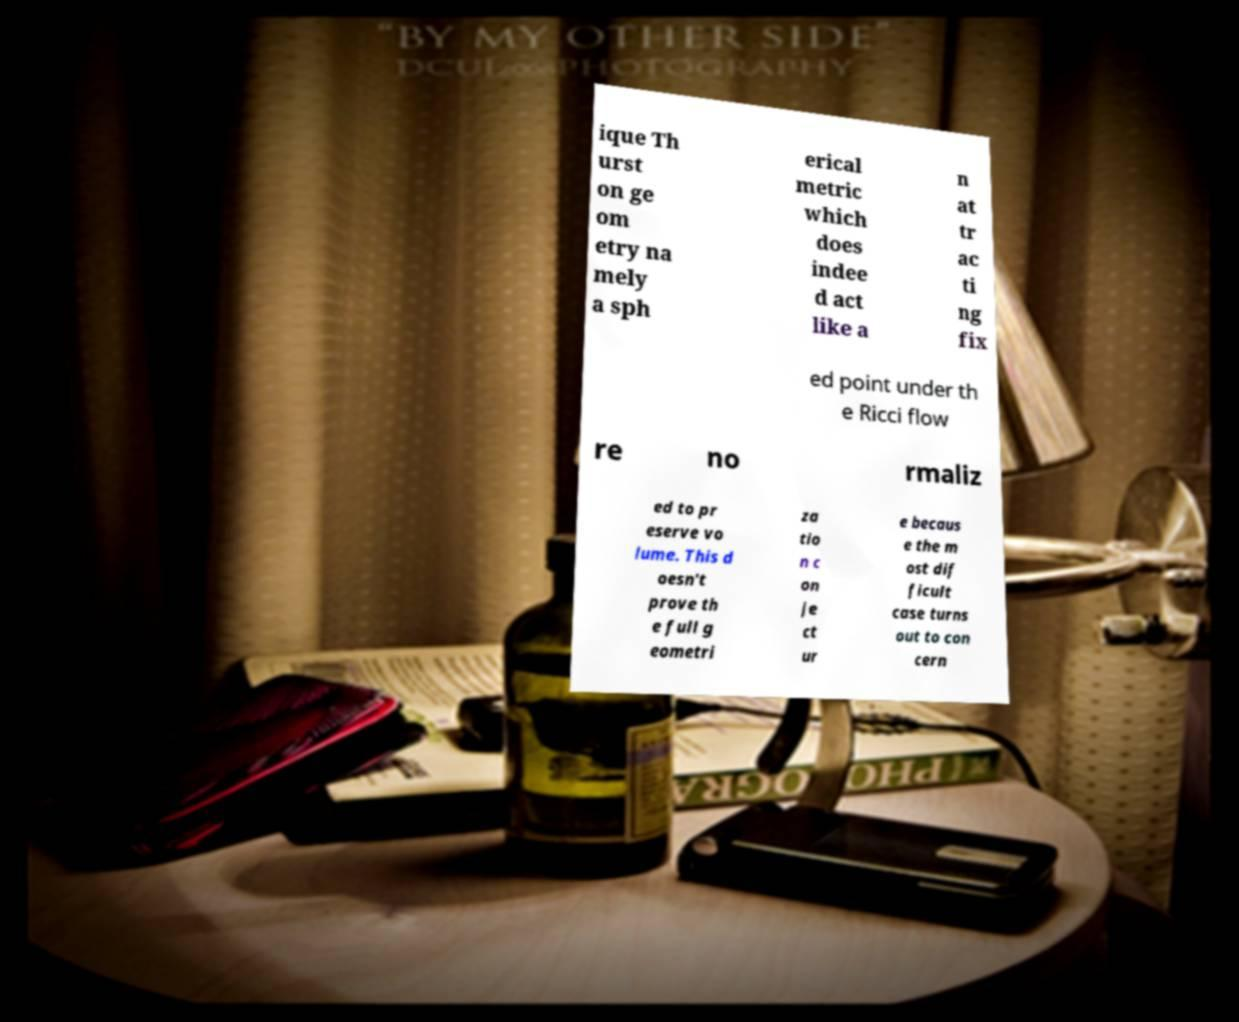I need the written content from this picture converted into text. Can you do that? ique Th urst on ge om etry na mely a sph erical metric which does indee d act like a n at tr ac ti ng fix ed point under th e Ricci flow re no rmaliz ed to pr eserve vo lume. This d oesn't prove th e full g eometri za tio n c on je ct ur e becaus e the m ost dif ficult case turns out to con cern 